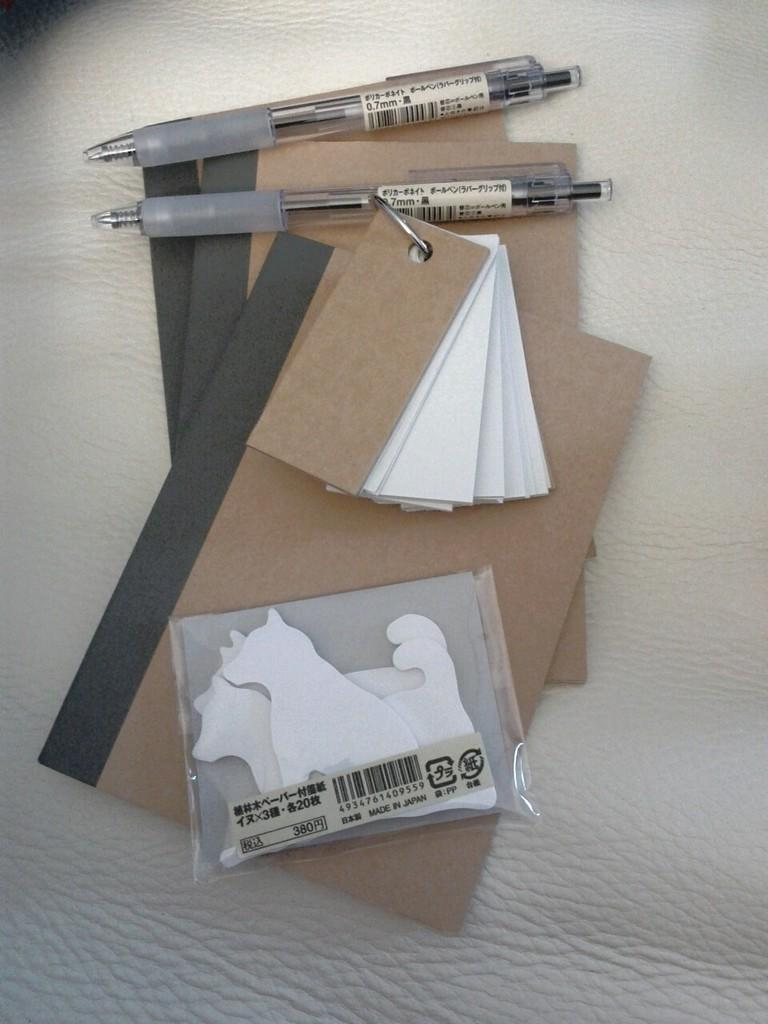What piece of furniture is present in the image? There is a table in the image. What items can be seen on the table? There are books, pens, and stickers on the table. How does the tray help to lift the books in the image? There is no tray present in the image, and therefore it cannot be used to lift the books. 